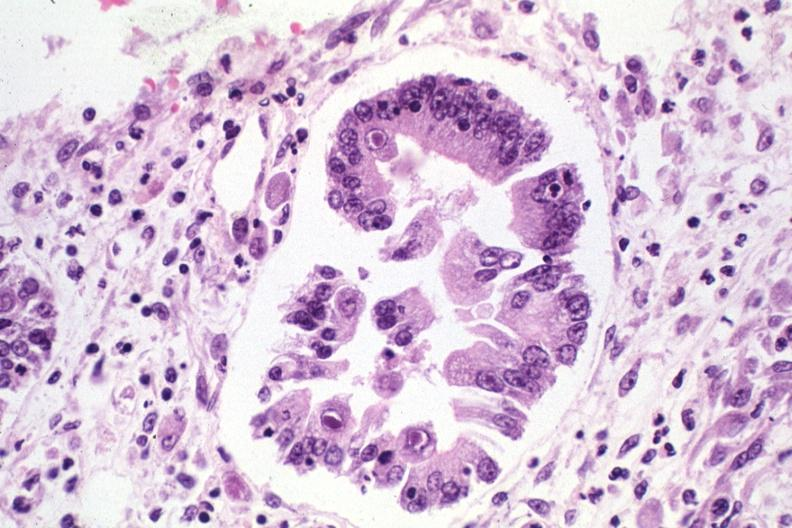what is present?
Answer the question using a single word or phrase. Cytomegalovirus 